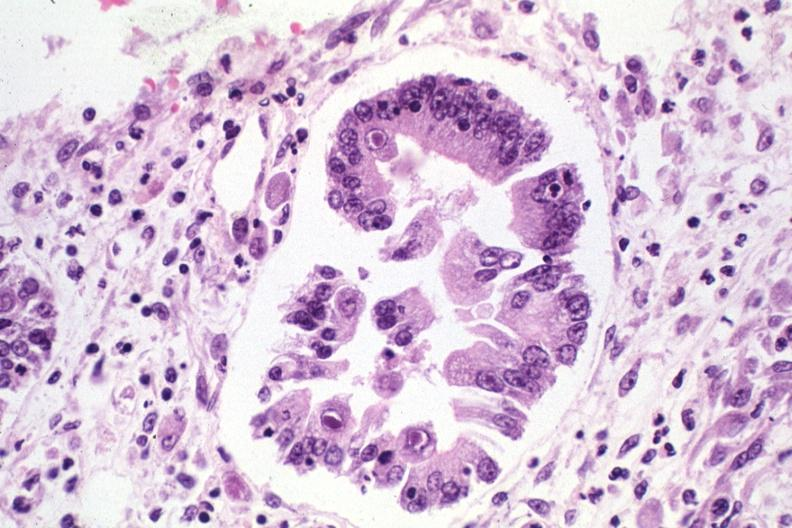what is present?
Answer the question using a single word or phrase. Cytomegalovirus 